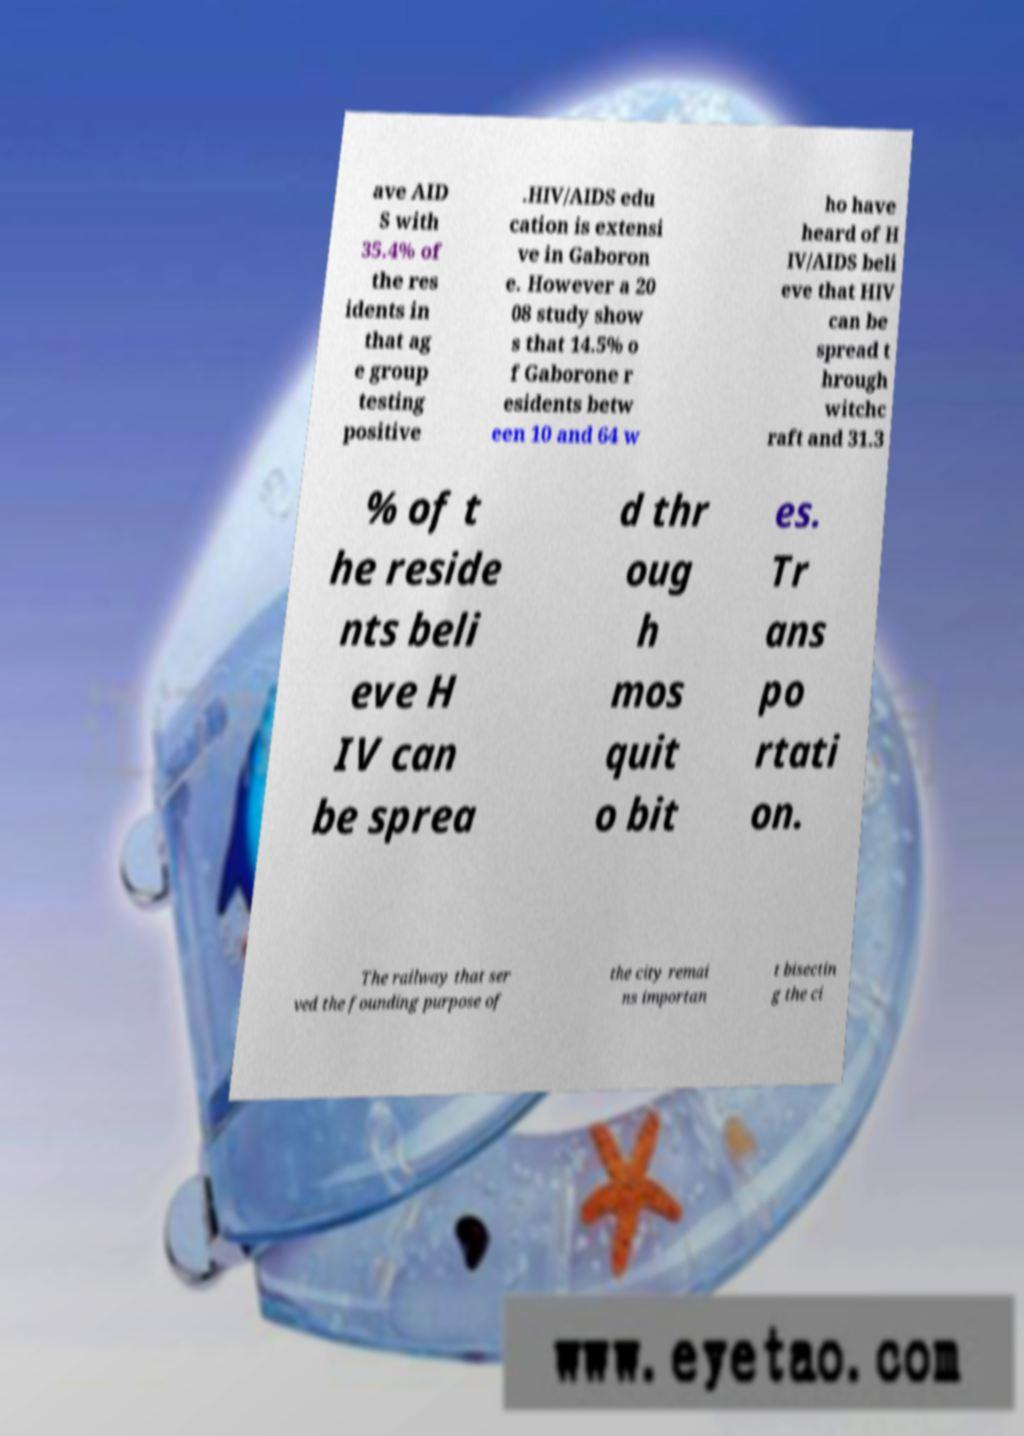Could you extract and type out the text from this image? ave AID S with 35.4% of the res idents in that ag e group testing positive .HIV/AIDS edu cation is extensi ve in Gaboron e. However a 20 08 study show s that 14.5% o f Gaborone r esidents betw een 10 and 64 w ho have heard of H IV/AIDS beli eve that HIV can be spread t hrough witchc raft and 31.3 % of t he reside nts beli eve H IV can be sprea d thr oug h mos quit o bit es. Tr ans po rtati on. The railway that ser ved the founding purpose of the city remai ns importan t bisectin g the ci 